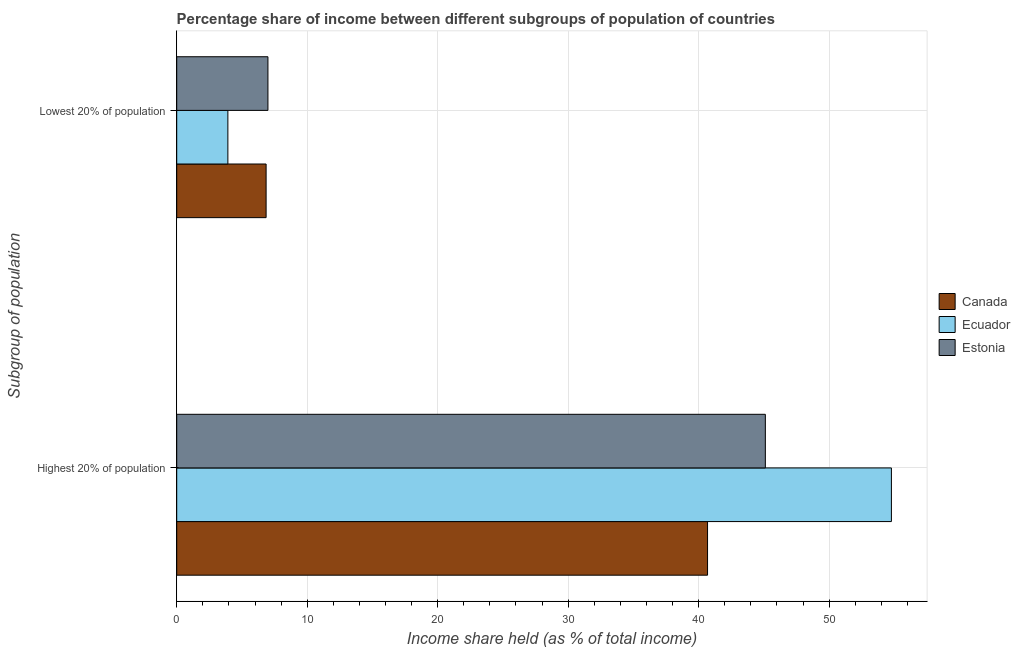How many groups of bars are there?
Offer a very short reply. 2. Are the number of bars per tick equal to the number of legend labels?
Ensure brevity in your answer.  Yes. Are the number of bars on each tick of the Y-axis equal?
Make the answer very short. Yes. How many bars are there on the 2nd tick from the bottom?
Offer a terse response. 3. What is the label of the 2nd group of bars from the top?
Your answer should be very brief. Highest 20% of population. What is the income share held by highest 20% of the population in Estonia?
Offer a very short reply. 45.11. Across all countries, what is the maximum income share held by highest 20% of the population?
Your answer should be compact. 54.77. Across all countries, what is the minimum income share held by lowest 20% of the population?
Your answer should be very brief. 3.92. In which country was the income share held by highest 20% of the population maximum?
Provide a short and direct response. Ecuador. What is the total income share held by lowest 20% of the population in the graph?
Keep it short and to the point. 17.76. What is the difference between the income share held by highest 20% of the population in Canada and that in Estonia?
Give a very brief answer. -4.43. What is the difference between the income share held by highest 20% of the population in Canada and the income share held by lowest 20% of the population in Estonia?
Ensure brevity in your answer.  33.69. What is the average income share held by lowest 20% of the population per country?
Give a very brief answer. 5.92. What is the difference between the income share held by lowest 20% of the population and income share held by highest 20% of the population in Canada?
Provide a succinct answer. -33.83. In how many countries, is the income share held by lowest 20% of the population greater than 24 %?
Offer a terse response. 0. What is the ratio of the income share held by lowest 20% of the population in Estonia to that in Ecuador?
Give a very brief answer. 1.78. What does the 2nd bar from the top in Highest 20% of population represents?
Provide a succinct answer. Ecuador. What does the 2nd bar from the bottom in Highest 20% of population represents?
Offer a terse response. Ecuador. Are all the bars in the graph horizontal?
Ensure brevity in your answer.  Yes. What is the difference between two consecutive major ticks on the X-axis?
Make the answer very short. 10. Are the values on the major ticks of X-axis written in scientific E-notation?
Ensure brevity in your answer.  No. Does the graph contain any zero values?
Your answer should be compact. No. Does the graph contain grids?
Your answer should be very brief. Yes. Where does the legend appear in the graph?
Ensure brevity in your answer.  Center right. What is the title of the graph?
Keep it short and to the point. Percentage share of income between different subgroups of population of countries. What is the label or title of the X-axis?
Your response must be concise. Income share held (as % of total income). What is the label or title of the Y-axis?
Your answer should be very brief. Subgroup of population. What is the Income share held (as % of total income) in Canada in Highest 20% of population?
Offer a very short reply. 40.68. What is the Income share held (as % of total income) in Ecuador in Highest 20% of population?
Your response must be concise. 54.77. What is the Income share held (as % of total income) in Estonia in Highest 20% of population?
Ensure brevity in your answer.  45.11. What is the Income share held (as % of total income) of Canada in Lowest 20% of population?
Ensure brevity in your answer.  6.85. What is the Income share held (as % of total income) of Ecuador in Lowest 20% of population?
Offer a terse response. 3.92. What is the Income share held (as % of total income) in Estonia in Lowest 20% of population?
Ensure brevity in your answer.  6.99. Across all Subgroup of population, what is the maximum Income share held (as % of total income) in Canada?
Ensure brevity in your answer.  40.68. Across all Subgroup of population, what is the maximum Income share held (as % of total income) of Ecuador?
Offer a terse response. 54.77. Across all Subgroup of population, what is the maximum Income share held (as % of total income) in Estonia?
Ensure brevity in your answer.  45.11. Across all Subgroup of population, what is the minimum Income share held (as % of total income) of Canada?
Your response must be concise. 6.85. Across all Subgroup of population, what is the minimum Income share held (as % of total income) in Ecuador?
Offer a terse response. 3.92. Across all Subgroup of population, what is the minimum Income share held (as % of total income) of Estonia?
Give a very brief answer. 6.99. What is the total Income share held (as % of total income) in Canada in the graph?
Make the answer very short. 47.53. What is the total Income share held (as % of total income) of Ecuador in the graph?
Provide a short and direct response. 58.69. What is the total Income share held (as % of total income) in Estonia in the graph?
Provide a succinct answer. 52.1. What is the difference between the Income share held (as % of total income) of Canada in Highest 20% of population and that in Lowest 20% of population?
Keep it short and to the point. 33.83. What is the difference between the Income share held (as % of total income) in Ecuador in Highest 20% of population and that in Lowest 20% of population?
Provide a short and direct response. 50.85. What is the difference between the Income share held (as % of total income) of Estonia in Highest 20% of population and that in Lowest 20% of population?
Offer a terse response. 38.12. What is the difference between the Income share held (as % of total income) of Canada in Highest 20% of population and the Income share held (as % of total income) of Ecuador in Lowest 20% of population?
Provide a short and direct response. 36.76. What is the difference between the Income share held (as % of total income) of Canada in Highest 20% of population and the Income share held (as % of total income) of Estonia in Lowest 20% of population?
Provide a succinct answer. 33.69. What is the difference between the Income share held (as % of total income) of Ecuador in Highest 20% of population and the Income share held (as % of total income) of Estonia in Lowest 20% of population?
Keep it short and to the point. 47.78. What is the average Income share held (as % of total income) of Canada per Subgroup of population?
Provide a short and direct response. 23.77. What is the average Income share held (as % of total income) in Ecuador per Subgroup of population?
Provide a succinct answer. 29.34. What is the average Income share held (as % of total income) of Estonia per Subgroup of population?
Offer a very short reply. 26.05. What is the difference between the Income share held (as % of total income) in Canada and Income share held (as % of total income) in Ecuador in Highest 20% of population?
Your response must be concise. -14.09. What is the difference between the Income share held (as % of total income) in Canada and Income share held (as % of total income) in Estonia in Highest 20% of population?
Your answer should be compact. -4.43. What is the difference between the Income share held (as % of total income) of Ecuador and Income share held (as % of total income) of Estonia in Highest 20% of population?
Provide a short and direct response. 9.66. What is the difference between the Income share held (as % of total income) in Canada and Income share held (as % of total income) in Ecuador in Lowest 20% of population?
Your answer should be very brief. 2.93. What is the difference between the Income share held (as % of total income) of Canada and Income share held (as % of total income) of Estonia in Lowest 20% of population?
Provide a succinct answer. -0.14. What is the difference between the Income share held (as % of total income) of Ecuador and Income share held (as % of total income) of Estonia in Lowest 20% of population?
Ensure brevity in your answer.  -3.07. What is the ratio of the Income share held (as % of total income) in Canada in Highest 20% of population to that in Lowest 20% of population?
Your answer should be compact. 5.94. What is the ratio of the Income share held (as % of total income) in Ecuador in Highest 20% of population to that in Lowest 20% of population?
Offer a terse response. 13.97. What is the ratio of the Income share held (as % of total income) of Estonia in Highest 20% of population to that in Lowest 20% of population?
Give a very brief answer. 6.45. What is the difference between the highest and the second highest Income share held (as % of total income) in Canada?
Offer a terse response. 33.83. What is the difference between the highest and the second highest Income share held (as % of total income) of Ecuador?
Ensure brevity in your answer.  50.85. What is the difference between the highest and the second highest Income share held (as % of total income) of Estonia?
Ensure brevity in your answer.  38.12. What is the difference between the highest and the lowest Income share held (as % of total income) in Canada?
Ensure brevity in your answer.  33.83. What is the difference between the highest and the lowest Income share held (as % of total income) in Ecuador?
Keep it short and to the point. 50.85. What is the difference between the highest and the lowest Income share held (as % of total income) of Estonia?
Provide a short and direct response. 38.12. 